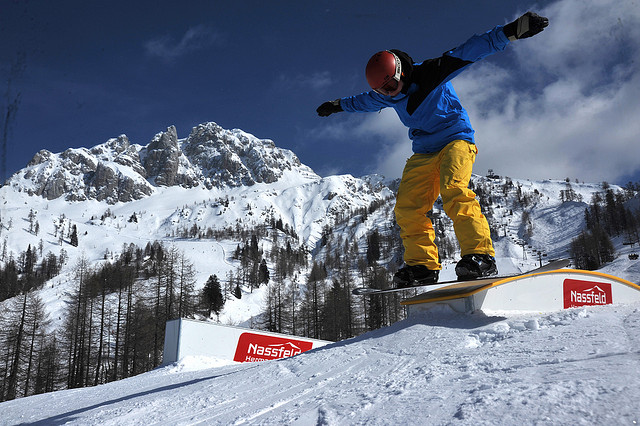Are there any spectators watching the snowboarder? From the visible parts of the image, there do not appear to be any spectators or an audience. It seems that the snowboarder is performing their trick in a serene, natural setting, possibly far from any crowds. 